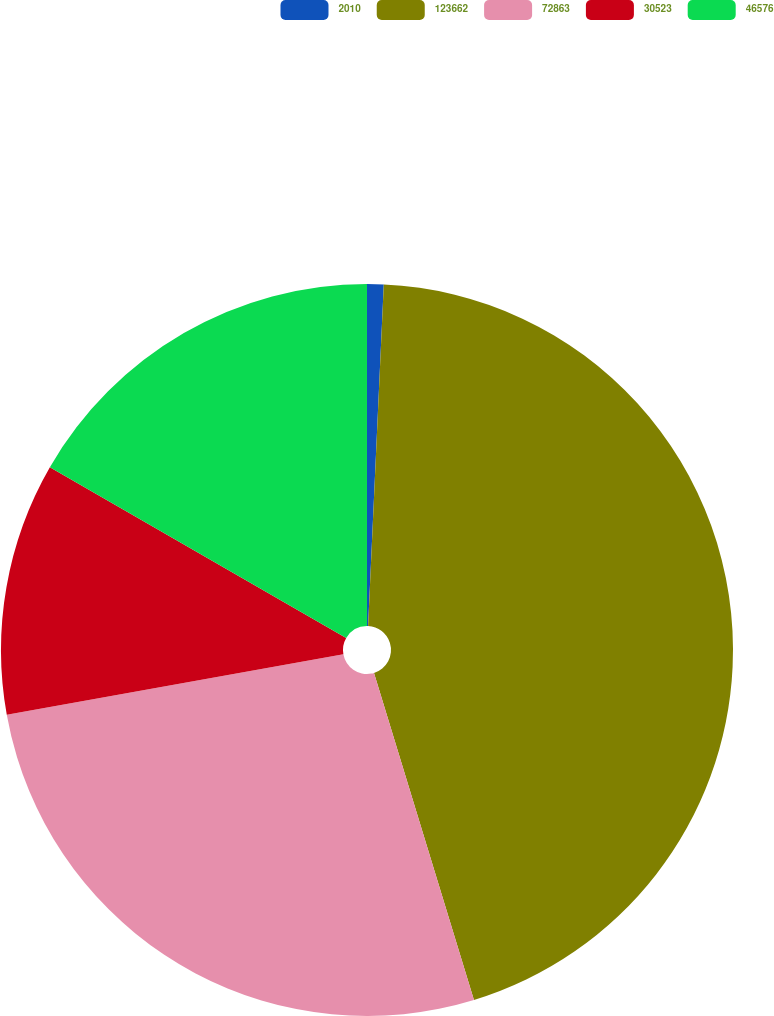Convert chart to OTSL. <chart><loc_0><loc_0><loc_500><loc_500><pie_chart><fcel>2010<fcel>123662<fcel>72863<fcel>30523<fcel>46576<nl><fcel>0.73%<fcel>44.55%<fcel>26.89%<fcel>11.15%<fcel>16.68%<nl></chart> 